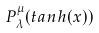<formula> <loc_0><loc_0><loc_500><loc_500>P _ { \lambda } ^ { \mu } ( t a n h ( x ) )</formula> 